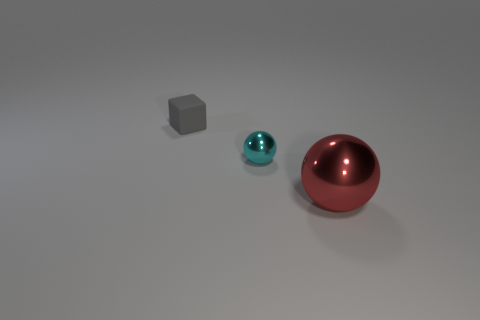Add 2 big brown shiny things. How many objects exist? 5 Subtract all cubes. How many objects are left? 2 Subtract 0 purple cubes. How many objects are left? 3 Subtract all large red cylinders. Subtract all matte blocks. How many objects are left? 2 Add 3 large red metallic spheres. How many large red metallic spheres are left? 4 Add 2 large red metallic things. How many large red metallic things exist? 3 